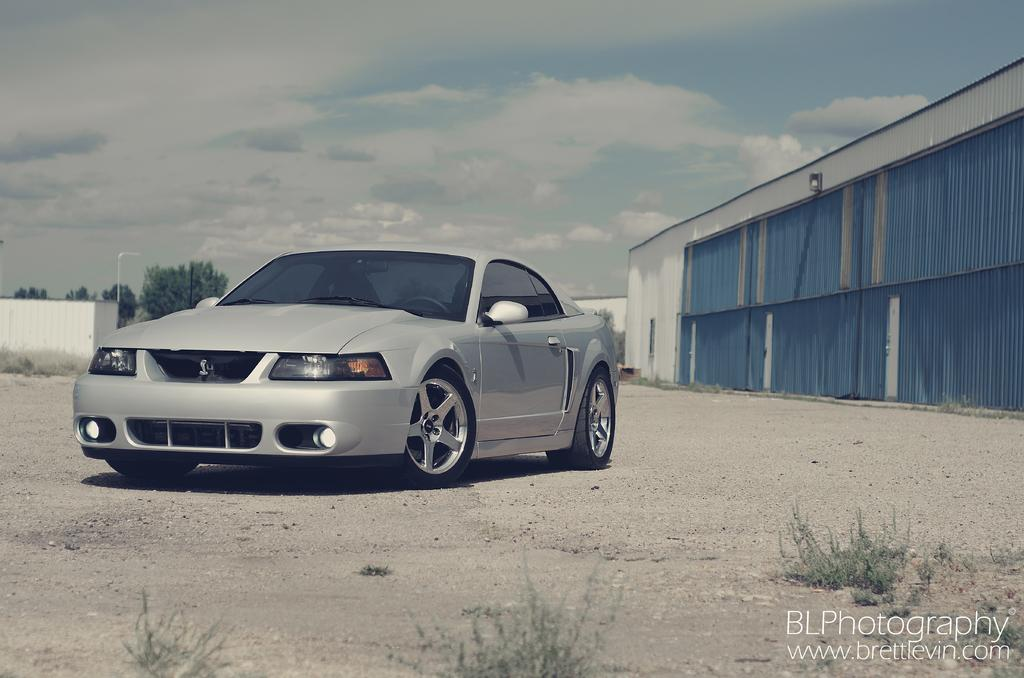What is located on the ground in the image? There is a car on the ground in the image. What type of vegetation can be seen in the image? There is grass visible in the image. What is located on the right side of the image? There is a building on the right side of the image. What other natural elements are present in the image? There are trees in the image. What is visible in the background of the image? The sky is visible in the background of the image. What type of hen can be seen in the image? There is no hen present in the image. 